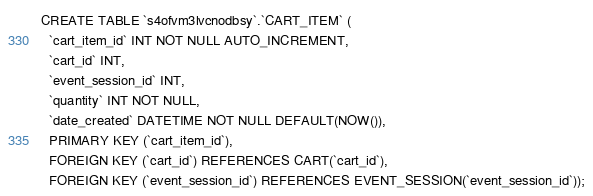Convert code to text. <code><loc_0><loc_0><loc_500><loc_500><_SQL_>CREATE TABLE `s4ofvm3lvcnodbsy`.`CART_ITEM` (
  `cart_item_id` INT NOT NULL AUTO_INCREMENT,
  `cart_id` INT,
  `event_session_id` INT,
  `quantity` INT NOT NULL,
  `date_created` DATETIME NOT NULL DEFAULT(NOW()),
  PRIMARY KEY (`cart_item_id`),
  FOREIGN KEY (`cart_id`) REFERENCES CART(`cart_id`),
  FOREIGN KEY (`event_session_id`) REFERENCES EVENT_SESSION(`event_session_id`));</code> 